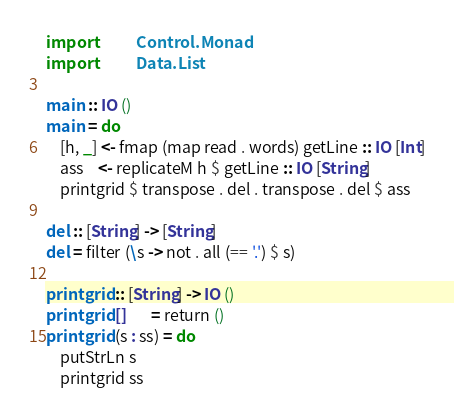Convert code to text. <code><loc_0><loc_0><loc_500><loc_500><_Haskell_>import           Control.Monad
import           Data.List

main :: IO ()
main = do
    [h, _] <- fmap (map read . words) getLine :: IO [Int]
    ass    <- replicateM h $ getLine :: IO [String]
    printgrid $ transpose . del . transpose . del $ ass

del :: [String] -> [String]
del = filter (\s -> not . all (== '.') $ s)

printgrid :: [String] -> IO ()
printgrid []       = return ()
printgrid (s : ss) = do
    putStrLn s
    printgrid ss
</code> 